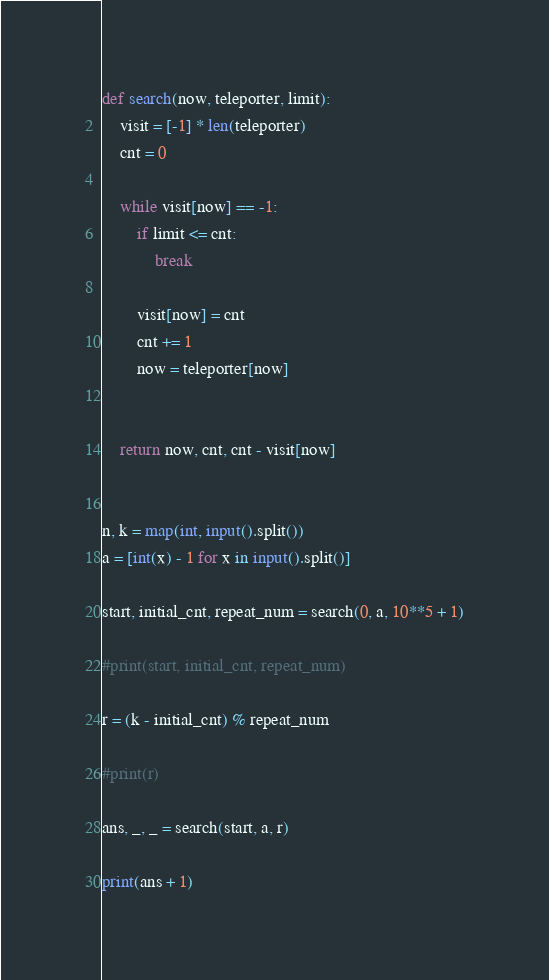<code> <loc_0><loc_0><loc_500><loc_500><_Python_>def search(now, teleporter, limit):
    visit = [-1] * len(teleporter)
    cnt = 0
    
    while visit[now] == -1:
        if limit <= cnt:
            break
        
        visit[now] = cnt
        cnt += 1
        now = teleporter[now]
        
    
    return now, cnt, cnt - visit[now]
    

n, k = map(int, input().split())
a = [int(x) - 1 for x in input().split()]

start, initial_cnt, repeat_num = search(0, a, 10**5 + 1)

#print(start, initial_cnt, repeat_num)

r = (k - initial_cnt) % repeat_num

#print(r)

ans, _, _ = search(start, a, r)

print(ans + 1)</code> 